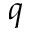Convert formula to latex. <formula><loc_0><loc_0><loc_500><loc_500>q</formula> 